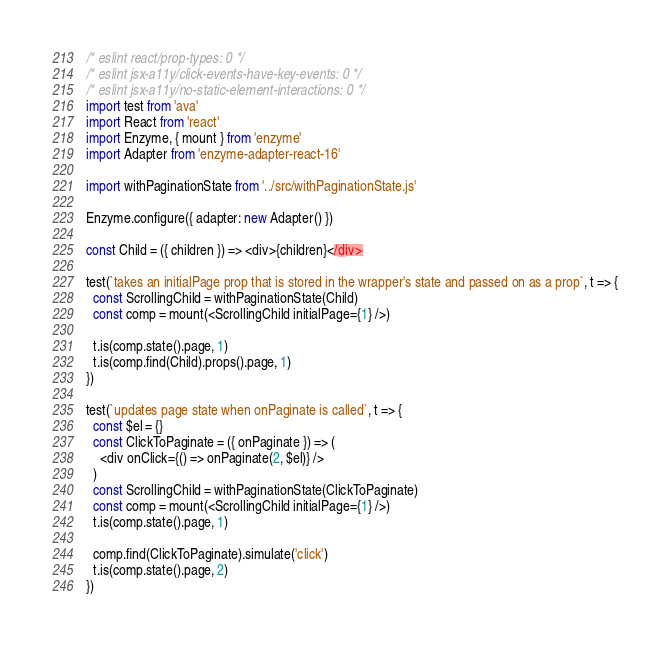<code> <loc_0><loc_0><loc_500><loc_500><_JavaScript_>/* eslint react/prop-types: 0 */
/* eslint jsx-a11y/click-events-have-key-events: 0 */
/* eslint jsx-a11y/no-static-element-interactions: 0 */
import test from 'ava'
import React from 'react'
import Enzyme, { mount } from 'enzyme'
import Adapter from 'enzyme-adapter-react-16'

import withPaginationState from '../src/withPaginationState.js'

Enzyme.configure({ adapter: new Adapter() })

const Child = ({ children }) => <div>{children}</div>

test(`takes an initialPage prop that is stored in the wrapper's state and passed on as a prop`, t => {
  const ScrollingChild = withPaginationState(Child)
  const comp = mount(<ScrollingChild initialPage={1} />)

  t.is(comp.state().page, 1)
  t.is(comp.find(Child).props().page, 1)
})

test(`updates page state when onPaginate is called`, t => {
  const $el = {}
  const ClickToPaginate = ({ onPaginate }) => (
    <div onClick={() => onPaginate(2, $el)} />
  )
  const ScrollingChild = withPaginationState(ClickToPaginate)
  const comp = mount(<ScrollingChild initialPage={1} />)
  t.is(comp.state().page, 1)

  comp.find(ClickToPaginate).simulate('click')
  t.is(comp.state().page, 2)
})
</code> 